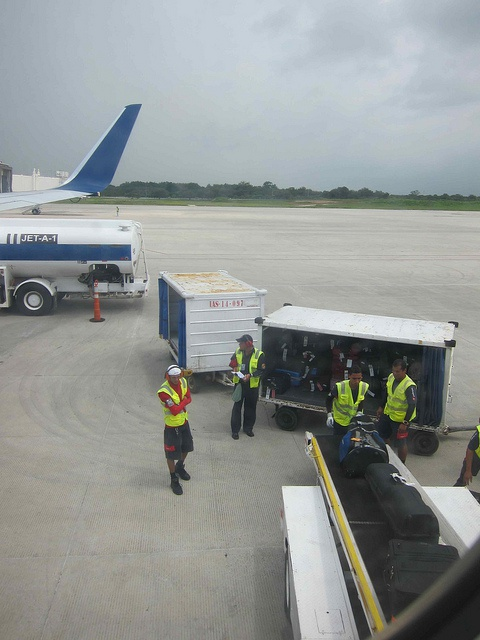Describe the objects in this image and their specific colors. I can see truck in darkgray, black, lightgray, and gray tones, truck in darkgray, black, lightgray, and gray tones, truck in darkgray, lightgray, gray, and blue tones, airplane in darkgray, blue, lightgray, and gray tones, and suitcase in darkgray, black, and gray tones in this image. 